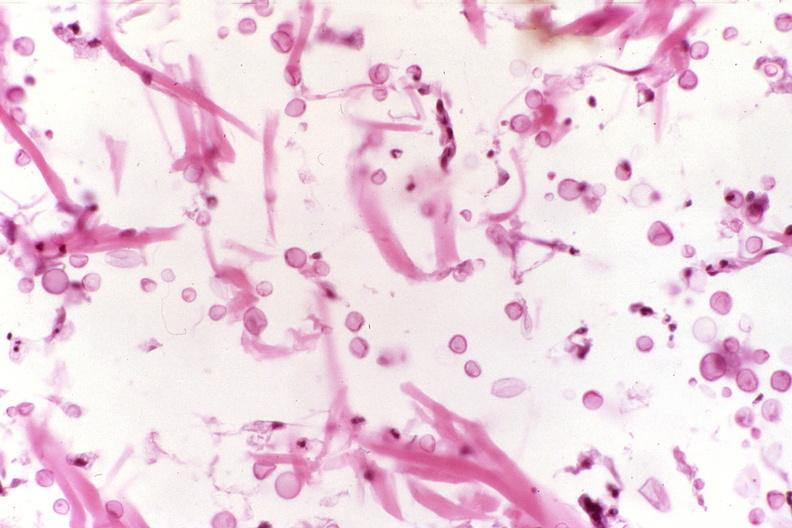where is this?
Answer the question using a single word or phrase. Skin 